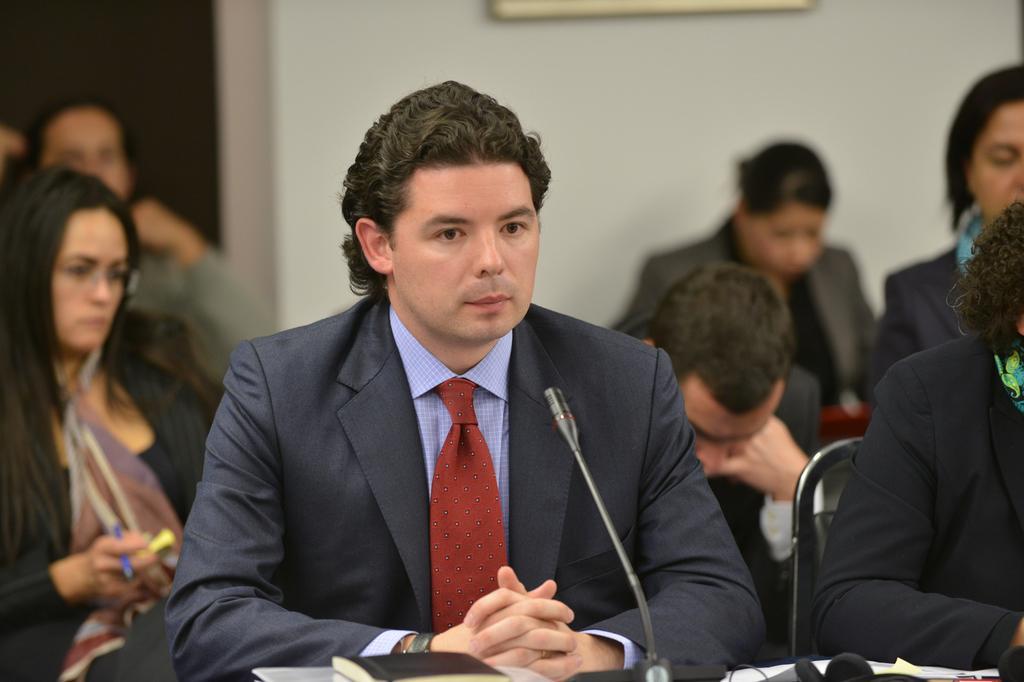In one or two sentences, can you explain what this image depicts? In the foreground of this picture, there is a man sitting in front of a mic and there is a mic, books, and few papers on the table. In the background, there are persons sitting on the chairs, wall, and a frame on it. 